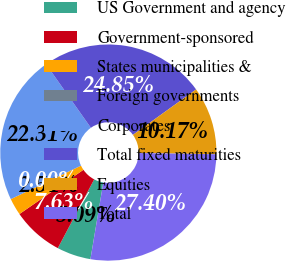Convert chart. <chart><loc_0><loc_0><loc_500><loc_500><pie_chart><fcel>US Government and agency<fcel>Government-sponsored<fcel>States municipalities &<fcel>Foreign governments<fcel>Corporates<fcel>Total fixed maturities<fcel>Equities<fcel>Total<nl><fcel>5.09%<fcel>7.63%<fcel>2.54%<fcel>0.0%<fcel>22.31%<fcel>24.85%<fcel>10.17%<fcel>27.4%<nl></chart> 